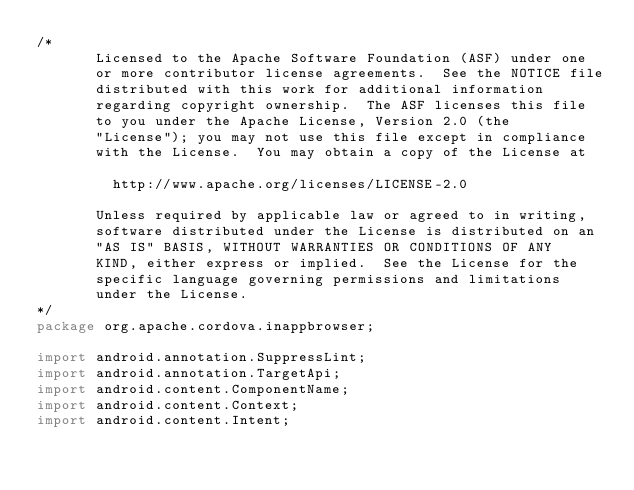<code> <loc_0><loc_0><loc_500><loc_500><_Java_>/*
       Licensed to the Apache Software Foundation (ASF) under one
       or more contributor license agreements.  See the NOTICE file
       distributed with this work for additional information
       regarding copyright ownership.  The ASF licenses this file
       to you under the Apache License, Version 2.0 (the
       "License"); you may not use this file except in compliance
       with the License.  You may obtain a copy of the License at

         http://www.apache.org/licenses/LICENSE-2.0

       Unless required by applicable law or agreed to in writing,
       software distributed under the License is distributed on an
       "AS IS" BASIS, WITHOUT WARRANTIES OR CONDITIONS OF ANY
       KIND, either express or implied.  See the License for the
       specific language governing permissions and limitations
       under the License.
*/
package org.apache.cordova.inappbrowser;

import android.annotation.SuppressLint;
import android.annotation.TargetApi;
import android.content.ComponentName;
import android.content.Context;
import android.content.Intent;</code> 